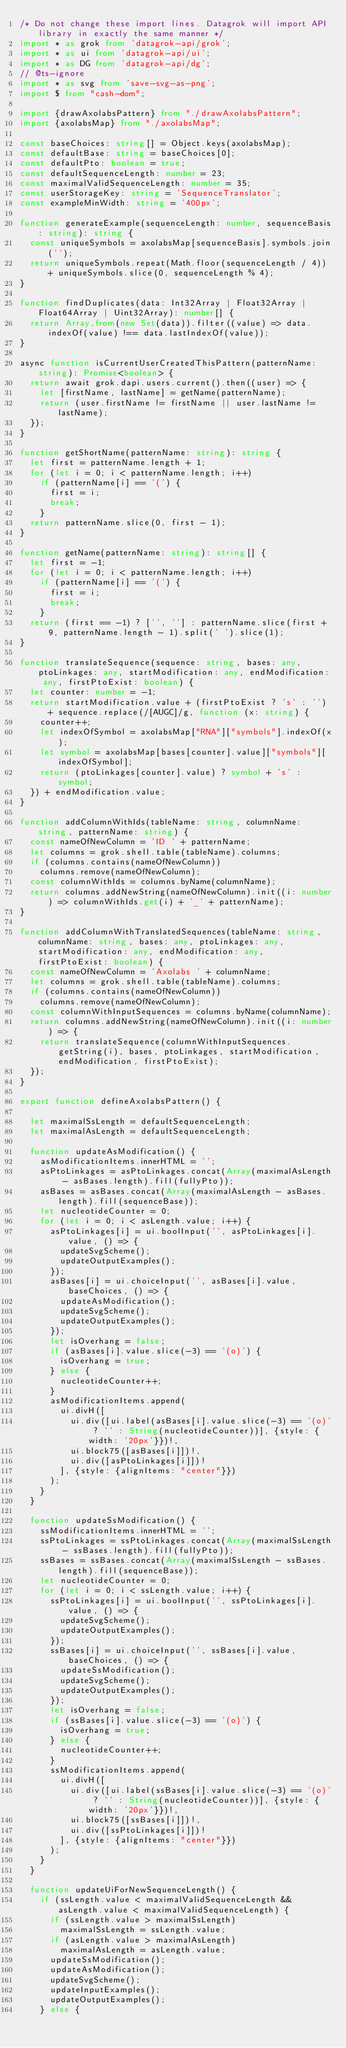Convert code to text. <code><loc_0><loc_0><loc_500><loc_500><_TypeScript_>/* Do not change these import lines. Datagrok will import API library in exactly the same manner */
import * as grok from 'datagrok-api/grok';
import * as ui from 'datagrok-api/ui';
import * as DG from 'datagrok-api/dg';
// @ts-ignore
import * as svg from 'save-svg-as-png';
import $ from "cash-dom";

import {drawAxolabsPattern} from "./drawAxolabsPattern";
import {axolabsMap} from "./axolabsMap";

const baseChoices: string[] = Object.keys(axolabsMap);
const defaultBase: string = baseChoices[0];
const defaultPto: boolean = true;
const defaultSequenceLength: number = 23;
const maximalValidSequenceLength: number = 35;
const userStorageKey: string = 'SequenceTranslator';
const exampleMinWidth: string = '400px';

function generateExample(sequenceLength: number, sequenceBasis: string): string {
  const uniqueSymbols = axolabsMap[sequenceBasis].symbols.join('');
  return uniqueSymbols.repeat(Math.floor(sequenceLength / 4)) + uniqueSymbols.slice(0, sequenceLength % 4);
}

function findDuplicates(data: Int32Array | Float32Array | Float64Array | Uint32Array): number[] {
  return Array.from(new Set(data)).filter((value) => data.indexOf(value) !== data.lastIndexOf(value));
}

async function isCurrentUserCreatedThisPattern(patternName: string): Promise<boolean> {
  return await grok.dapi.users.current().then((user) => {
    let [firstName, lastName] = getName(patternName);
    return (user.firstName != firstName || user.lastName != lastName);
  });
}

function getShortName(patternName: string): string {
  let first = patternName.length + 1;
  for (let i = 0; i < patternName.length; i++)
    if (patternName[i] == '(') {
      first = i;
      break;
    }
  return patternName.slice(0, first - 1);
}

function getName(patternName: string): string[] {
  let first = -1;
  for (let i = 0; i < patternName.length; i++)
    if (patternName[i] == '(') {
      first = i;
      break;
    }
  return (first == -1) ? ['', ''] : patternName.slice(first + 9, patternName.length - 1).split(' ').slice(1);
}

function translateSequence(sequence: string, bases: any, ptoLinkages: any, startModification: any, endModification: any, firstPtoExist: boolean) {
  let counter: number = -1;
  return startModification.value + (firstPtoExist ? 's' : '') + sequence.replace(/[AUGC]/g, function (x: string) {
    counter++;
    let indexOfSymbol = axolabsMap["RNA"]["symbols"].indexOf(x);
    let symbol = axolabsMap[bases[counter].value]["symbols"][indexOfSymbol];
    return (ptoLinkages[counter].value) ? symbol + 's' : symbol;
  }) + endModification.value;
}

function addColumnWithIds(tableName: string, columnName: string, patternName: string) {
  const nameOfNewColumn = 'ID ' + patternName;
  let columns = grok.shell.table(tableName).columns;
  if (columns.contains(nameOfNewColumn))
    columns.remove(nameOfNewColumn);
  const columnWithIds = columns.byName(columnName);
  return columns.addNewString(nameOfNewColumn).init((i: number) => columnWithIds.get(i) + '_' + patternName);
}

function addColumnWithTranslatedSequences(tableName: string, columnName: string, bases: any, ptoLinkages: any, startModification: any, endModification: any, firstPtoExist: boolean) {
  const nameOfNewColumn = 'Axolabs ' + columnName;
  let columns = grok.shell.table(tableName).columns;
  if (columns.contains(nameOfNewColumn))
    columns.remove(nameOfNewColumn);
  const columnWithInputSequences = columns.byName(columnName);
  return columns.addNewString(nameOfNewColumn).init((i: number) => {
    return translateSequence(columnWithInputSequences.getString(i), bases, ptoLinkages, startModification, endModification, firstPtoExist);
  });
}

export function defineAxolabsPattern() {

  let maximalSsLength = defaultSequenceLength;
  let maximalAsLength = defaultSequenceLength;

  function updateAsModification() {
    asModificationItems.innerHTML = '';
    asPtoLinkages = asPtoLinkages.concat(Array(maximalAsLength - asBases.length).fill(fullyPto));
    asBases = asBases.concat(Array(maximalAsLength - asBases.length).fill(sequenceBase));
    let nucleotideCounter = 0;
    for (let i = 0; i < asLength.value; i++) {
      asPtoLinkages[i] = ui.boolInput('', asPtoLinkages[i].value, () => {
        updateSvgScheme();
        updateOutputExamples();
      });
      asBases[i] = ui.choiceInput('', asBases[i].value, baseChoices, () => {
        updateAsModification();
        updateSvgScheme();
        updateOutputExamples();
      });
      let isOverhang = false;
      if (asBases[i].value.slice(-3) == '(o)') {
        isOverhang = true;
      } else {
        nucleotideCounter++;
      }
      asModificationItems.append(
        ui.divH([
          ui.div([ui.label(asBases[i].value.slice(-3) == '(o)' ? '' : String(nucleotideCounter))], {style: {width: '20px'}})!,
          ui.block75([asBases[i]])!,
          ui.div([asPtoLinkages[i]])!
        ], {style: {alignItems: "center"}})
      );
    }
  }

  function updateSsModification() {
    ssModificationItems.innerHTML = '';
    ssPtoLinkages = ssPtoLinkages.concat(Array(maximalSsLength - ssBases.length).fill(fullyPto));
    ssBases = ssBases.concat(Array(maximalSsLength - ssBases.length).fill(sequenceBase));
    let nucleotideCounter = 0;
    for (let i = 0; i < ssLength.value; i++) {
      ssPtoLinkages[i] = ui.boolInput('', ssPtoLinkages[i].value, () => {
        updateSvgScheme();
        updateOutputExamples();
      });
      ssBases[i] = ui.choiceInput('', ssBases[i].value, baseChoices, () => {
        updateSsModification();
        updateSvgScheme();
        updateOutputExamples();
      });
      let isOverhang = false;
      if (ssBases[i].value.slice(-3) == '(o)') {
        isOverhang = true;
      } else {
        nucleotideCounter++;
      }
      ssModificationItems.append(
        ui.divH([
          ui.div([ui.label(ssBases[i].value.slice(-3) == '(o)' ? '' : String(nucleotideCounter))], {style: {width: '20px'}})!,
          ui.block75([ssBases[i]])!,
          ui.div([ssPtoLinkages[i]])!
        ], {style: {alignItems: "center"}})
      );
    }
  }

  function updateUiForNewSequenceLength() {
    if (ssLength.value < maximalValidSequenceLength && asLength.value < maximalValidSequenceLength) {
      if (ssLength.value > maximalSsLength)
        maximalSsLength = ssLength.value;
      if (asLength.value > maximalAsLength)
        maximalAsLength = asLength.value;
      updateSsModification();
      updateAsModification();
      updateSvgScheme();
      updateInputExamples();
      updateOutputExamples();
    } else {</code> 